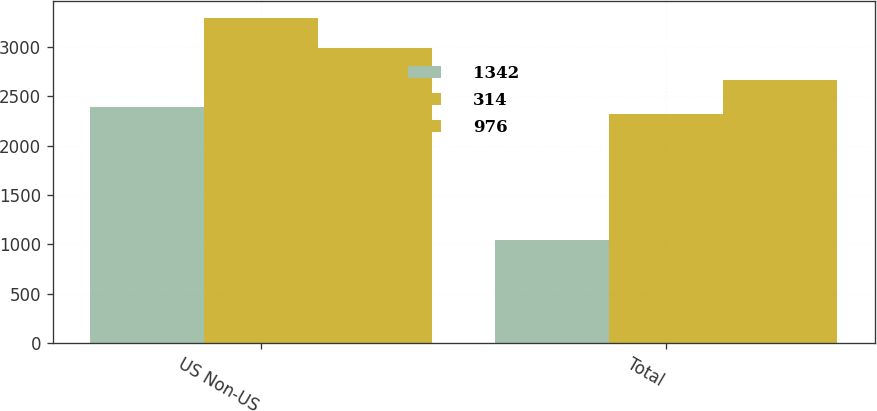Convert chart. <chart><loc_0><loc_0><loc_500><loc_500><stacked_bar_chart><ecel><fcel>US Non-US<fcel>Total<nl><fcel>1342<fcel>2386<fcel>1044<nl><fcel>314<fcel>3292<fcel>2316<nl><fcel>976<fcel>2981<fcel>2667<nl></chart> 